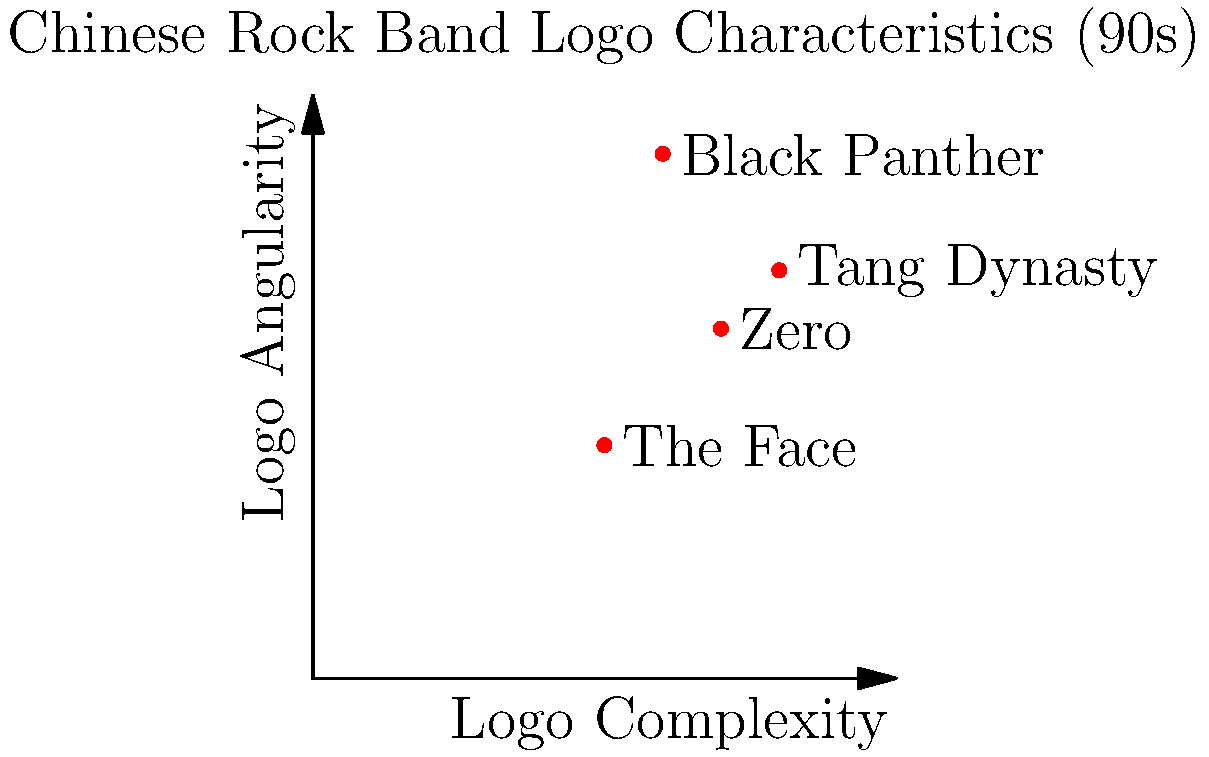Based on the scatter plot of Chinese rock band logo characteristics from the 90s, which band's logo is likely to be the most challenging for an image classification model to distinguish from other logos, and why? To determine which band's logo would be the most challenging for an image classification model, we need to consider the following steps:

1. Analyze the scatter plot:
   - The x-axis represents logo complexity
   - The y-axis represents logo angularity
   - Each point represents a band's logo characteristics

2. Consider the factors that make image classification challenging:
   - Logos that are similar to others in terms of complexity and angularity are harder to distinguish
   - Logos with average characteristics (closer to the center of the plot) may be more difficult to classify

3. Examine each band's logo position:
   - Tang Dynasty: High complexity (0.8), moderate-high angularity (0.7)
   - Black Panther: Moderate complexity (0.6), very high angularity (0.9)
   - The Face: Moderate complexity (0.5), low angularity (0.4)
   - Zero: Moderate-high complexity (0.7), moderate angularity (0.6)

4. Identify the logo with the most average characteristics:
   - Zero's logo is closest to the center of the plot, with moderate-high complexity and moderate angularity

5. Consider the uniqueness of each logo's position:
   - Tang Dynasty, Black Panther, and The Face have more distinct positions
   - Zero's logo is relatively close to the others, especially Tang Dynasty

Based on this analysis, Zero's logo is likely to be the most challenging for an image classification model to distinguish. Its characteristics are the most average among the group, and it doesn't have a unique position in the complexity-angularity space like the other bands.
Answer: Zero 